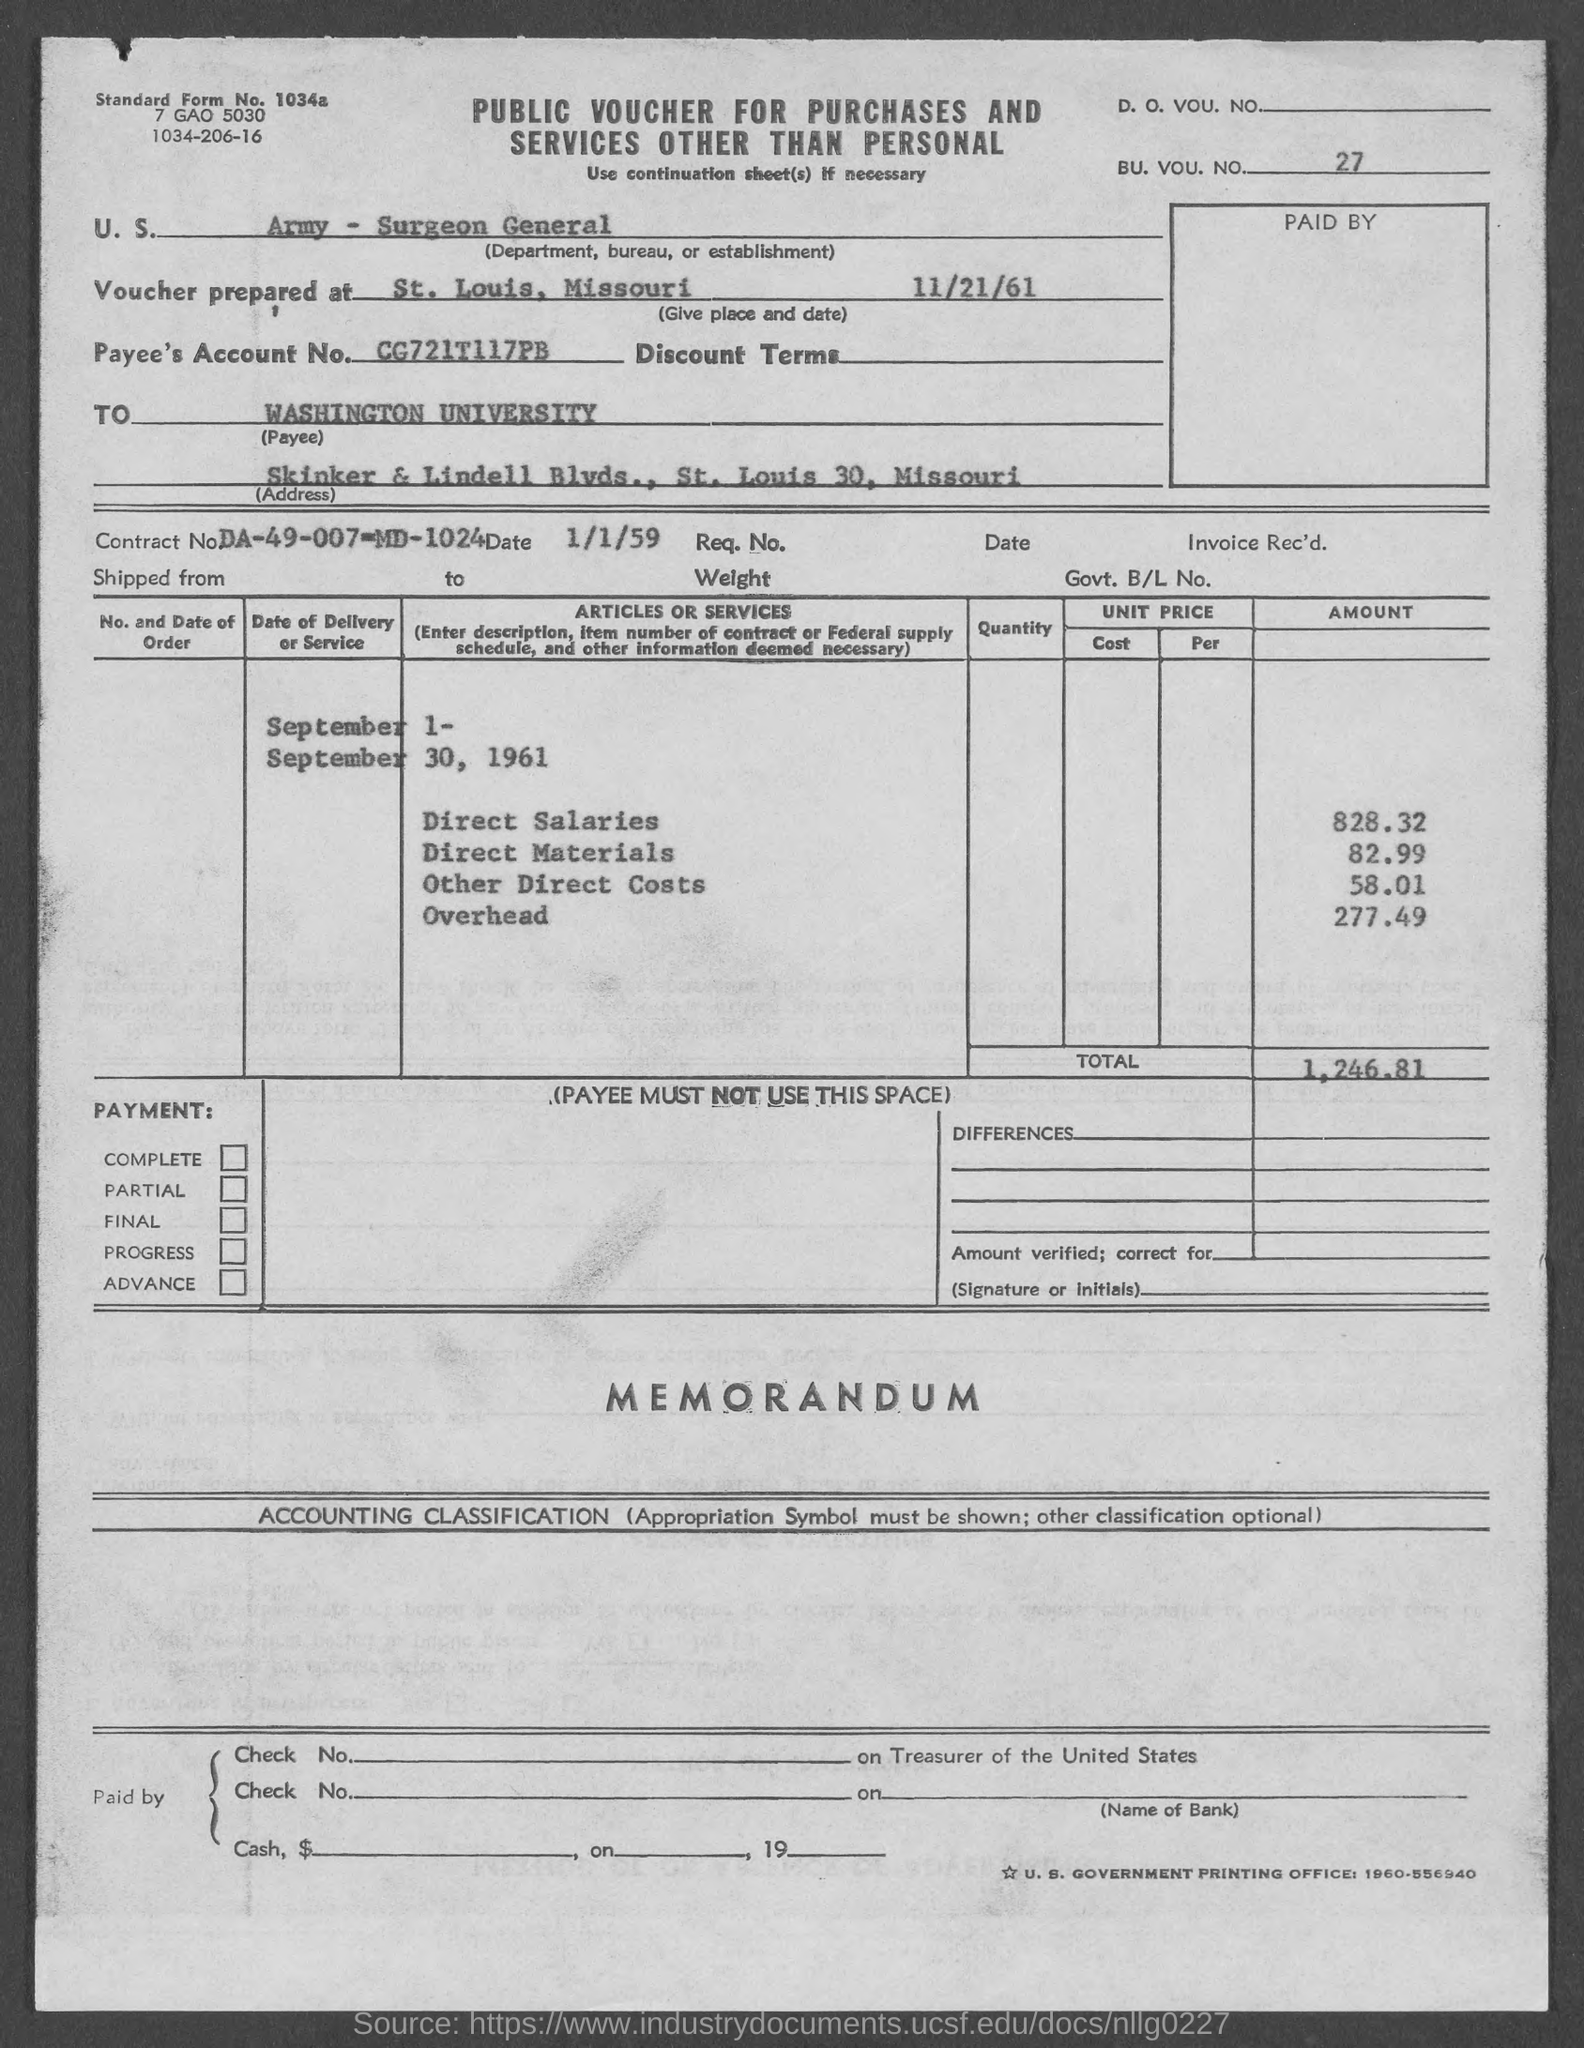What details can you provide about the payer and payee of this transaction? The voucher is prepared by the U.S. Army - Surgeon General, located in St. Louis, Missouri, and is addressed to Washington University at Skinner & Lindell Blvds, St. Louis 30, Missouri. 